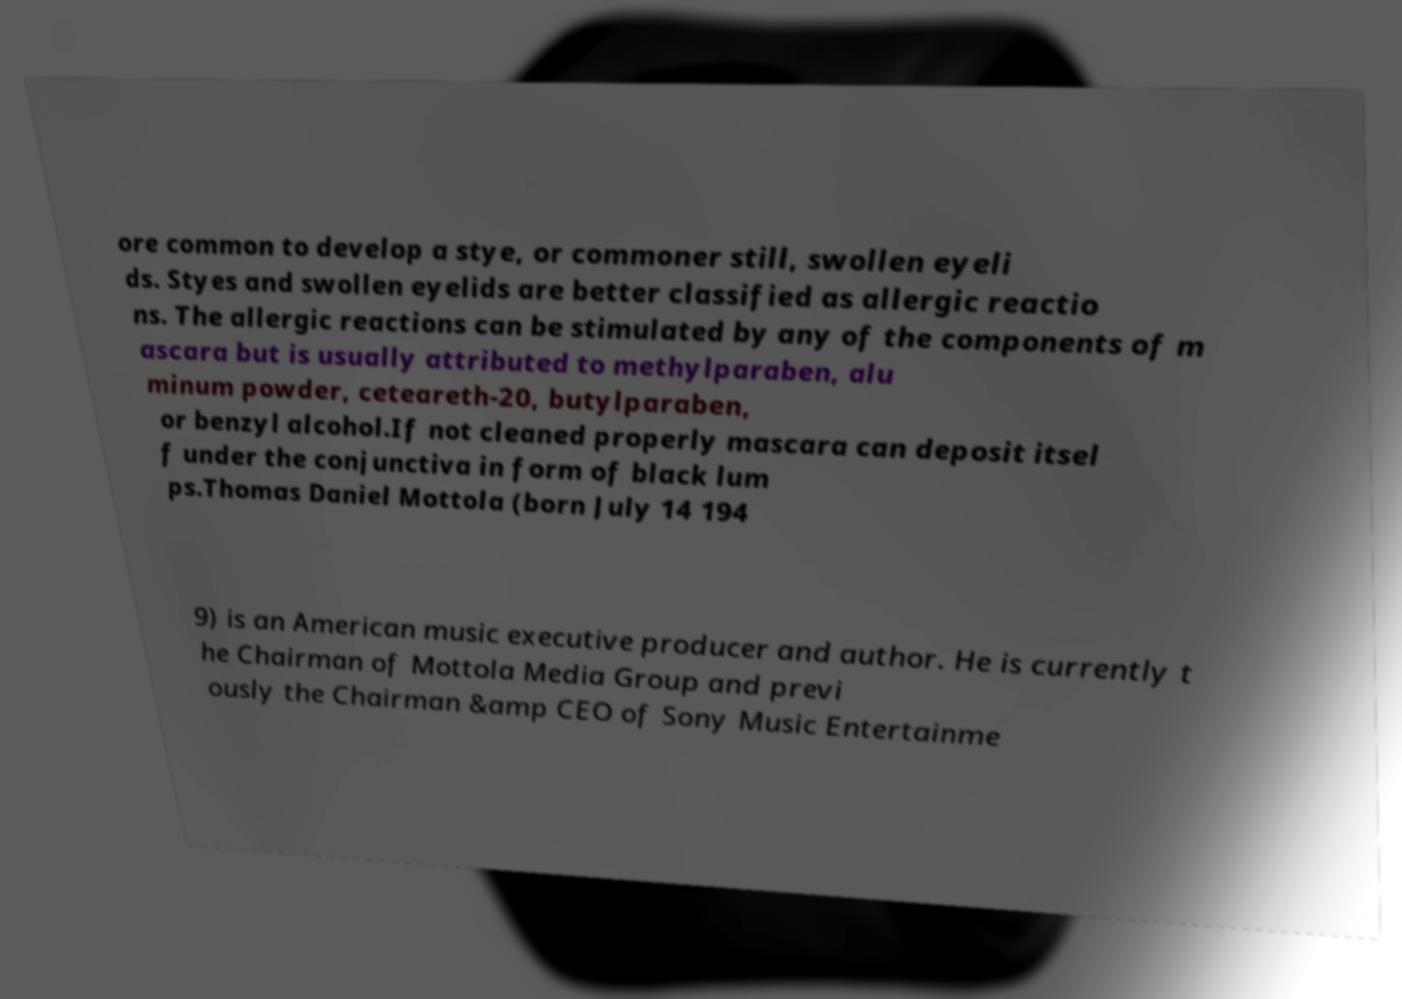What messages or text are displayed in this image? I need them in a readable, typed format. ore common to develop a stye, or commoner still, swollen eyeli ds. Styes and swollen eyelids are better classified as allergic reactio ns. The allergic reactions can be stimulated by any of the components of m ascara but is usually attributed to methylparaben, alu minum powder, ceteareth-20, butylparaben, or benzyl alcohol.If not cleaned properly mascara can deposit itsel f under the conjunctiva in form of black lum ps.Thomas Daniel Mottola (born July 14 194 9) is an American music executive producer and author. He is currently t he Chairman of Mottola Media Group and previ ously the Chairman &amp CEO of Sony Music Entertainme 